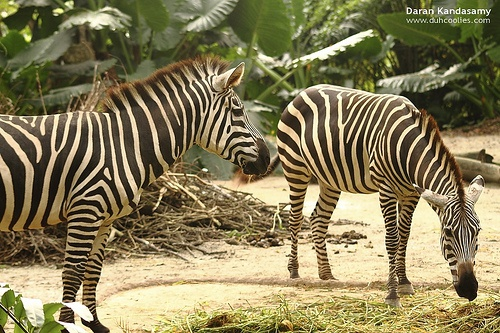Describe the objects in this image and their specific colors. I can see zebra in olive, black, tan, and gray tones and zebra in olive, black, gray, and tan tones in this image. 